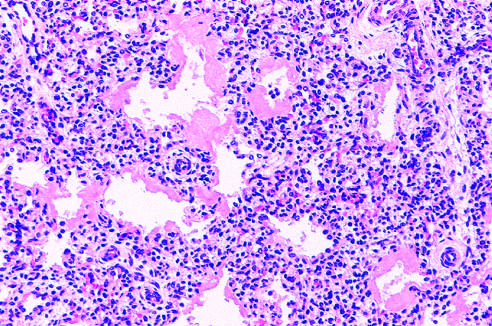s this hematoxylin-eosin stain?
Answer the question using a single word or phrase. Yes 